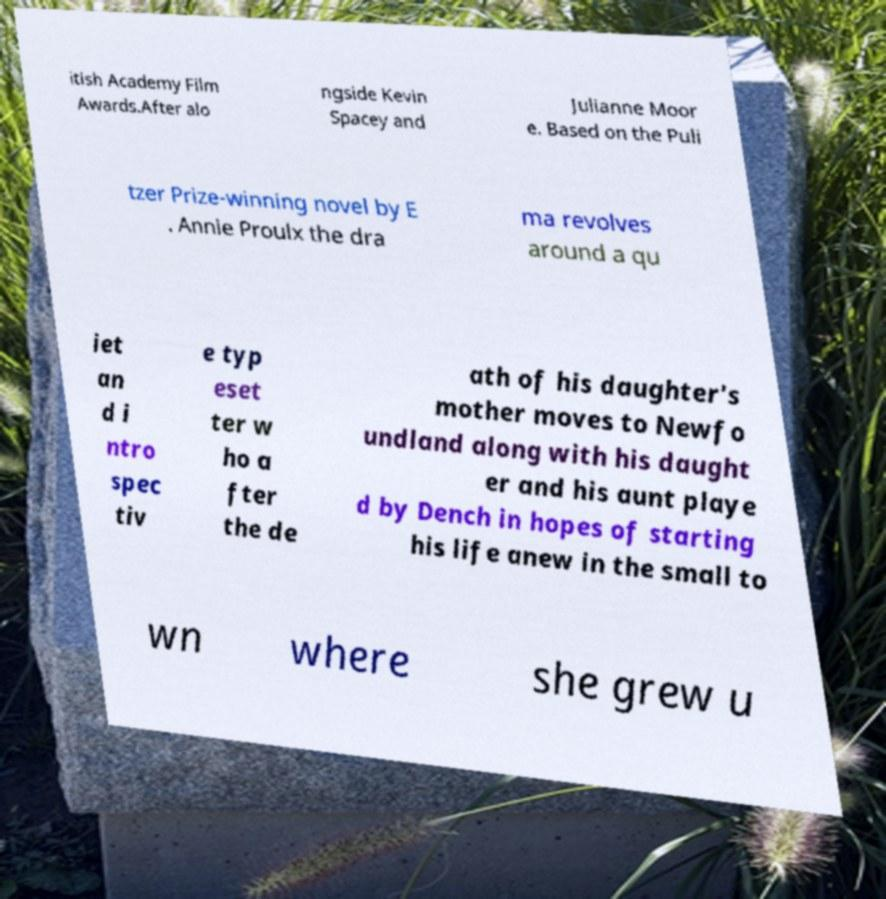Can you accurately transcribe the text from the provided image for me? itish Academy Film Awards.After alo ngside Kevin Spacey and Julianne Moor e. Based on the Puli tzer Prize-winning novel by E . Annie Proulx the dra ma revolves around a qu iet an d i ntro spec tiv e typ eset ter w ho a fter the de ath of his daughter's mother moves to Newfo undland along with his daught er and his aunt playe d by Dench in hopes of starting his life anew in the small to wn where she grew u 